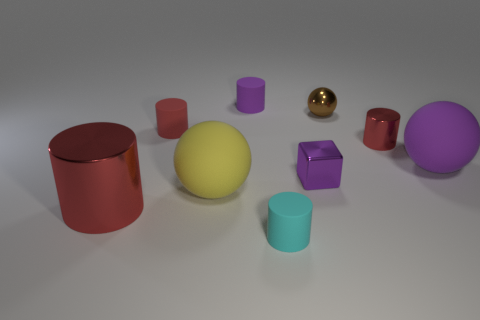What can we infer about the texture of objects in this setting? From the image, we can infer a variety of textures. The majority of objects exhibit a matte texture, diffusing light gently, which suggests a soft or non-reflective surface. However, there is an exception with the golden sphere, which has a glossy, reflective quality, indicating a smoother and possibly metallic surface. 